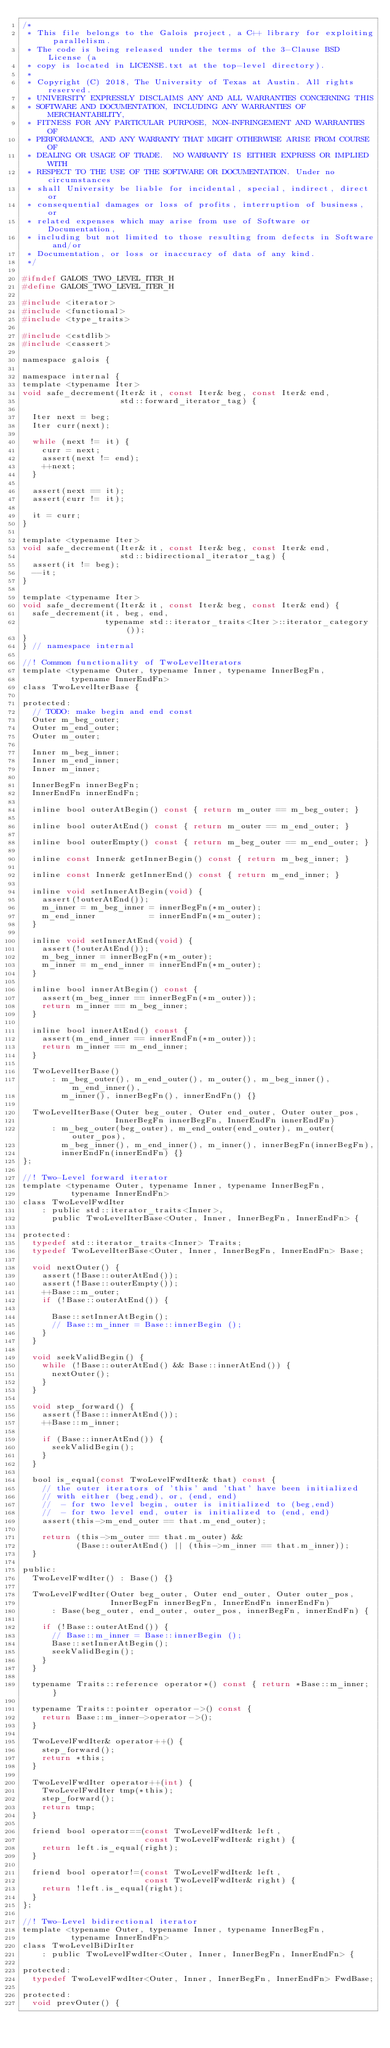<code> <loc_0><loc_0><loc_500><loc_500><_C_>/*
 * This file belongs to the Galois project, a C++ library for exploiting parallelism.
 * The code is being released under the terms of the 3-Clause BSD License (a
 * copy is located in LICENSE.txt at the top-level directory).
 *
 * Copyright (C) 2018, The University of Texas at Austin. All rights reserved.
 * UNIVERSITY EXPRESSLY DISCLAIMS ANY AND ALL WARRANTIES CONCERNING THIS
 * SOFTWARE AND DOCUMENTATION, INCLUDING ANY WARRANTIES OF MERCHANTABILITY,
 * FITNESS FOR ANY PARTICULAR PURPOSE, NON-INFRINGEMENT AND WARRANTIES OF
 * PERFORMANCE, AND ANY WARRANTY THAT MIGHT OTHERWISE ARISE FROM COURSE OF
 * DEALING OR USAGE OF TRADE.  NO WARRANTY IS EITHER EXPRESS OR IMPLIED WITH
 * RESPECT TO THE USE OF THE SOFTWARE OR DOCUMENTATION. Under no circumstances
 * shall University be liable for incidental, special, indirect, direct or
 * consequential damages or loss of profits, interruption of business, or
 * related expenses which may arise from use of Software or Documentation,
 * including but not limited to those resulting from defects in Software and/or
 * Documentation, or loss or inaccuracy of data of any kind.
 */

#ifndef GALOIS_TWO_LEVEL_ITER_H
#define GALOIS_TWO_LEVEL_ITER_H

#include <iterator>
#include <functional>
#include <type_traits>

#include <cstdlib>
#include <cassert>

namespace galois {

namespace internal {
template <typename Iter>
void safe_decrement(Iter& it, const Iter& beg, const Iter& end,
                    std::forward_iterator_tag) {

  Iter next = beg;
  Iter curr(next);

  while (next != it) {
    curr = next;
    assert(next != end);
    ++next;
  }

  assert(next == it);
  assert(curr != it);

  it = curr;
}

template <typename Iter>
void safe_decrement(Iter& it, const Iter& beg, const Iter& end,
                    std::bidirectional_iterator_tag) {
  assert(it != beg);
  --it;
}

template <typename Iter>
void safe_decrement(Iter& it, const Iter& beg, const Iter& end) {
  safe_decrement(it, beg, end,
                 typename std::iterator_traits<Iter>::iterator_category());
}
} // namespace internal

//! Common functionality of TwoLevelIterators
template <typename Outer, typename Inner, typename InnerBegFn,
          typename InnerEndFn>
class TwoLevelIterBase {

protected:
  // TODO: make begin and end const
  Outer m_beg_outer;
  Outer m_end_outer;
  Outer m_outer;

  Inner m_beg_inner;
  Inner m_end_inner;
  Inner m_inner;

  InnerBegFn innerBegFn;
  InnerEndFn innerEndFn;

  inline bool outerAtBegin() const { return m_outer == m_beg_outer; }

  inline bool outerAtEnd() const { return m_outer == m_end_outer; }

  inline bool outerEmpty() const { return m_beg_outer == m_end_outer; }

  inline const Inner& getInnerBegin() const { return m_beg_inner; }

  inline const Inner& getInnerEnd() const { return m_end_inner; }

  inline void setInnerAtBegin(void) {
    assert(!outerAtEnd());
    m_inner = m_beg_inner = innerBegFn(*m_outer);
    m_end_inner           = innerEndFn(*m_outer);
  }

  inline void setInnerAtEnd(void) {
    assert(!outerAtEnd());
    m_beg_inner = innerBegFn(*m_outer);
    m_inner = m_end_inner = innerEndFn(*m_outer);
  }

  inline bool innerAtBegin() const {
    assert(m_beg_inner == innerBegFn(*m_outer));
    return m_inner == m_beg_inner;
  }

  inline bool innerAtEnd() const {
    assert(m_end_inner == innerEndFn(*m_outer));
    return m_inner == m_end_inner;
  }

  TwoLevelIterBase()
      : m_beg_outer(), m_end_outer(), m_outer(), m_beg_inner(), m_end_inner(),
        m_inner(), innerBegFn(), innerEndFn() {}

  TwoLevelIterBase(Outer beg_outer, Outer end_outer, Outer outer_pos,
                   InnerBegFn innerBegFn, InnerEndFn innerEndFn)
      : m_beg_outer(beg_outer), m_end_outer(end_outer), m_outer(outer_pos),
        m_beg_inner(), m_end_inner(), m_inner(), innerBegFn(innerBegFn),
        innerEndFn(innerEndFn) {}
};

//! Two-Level forward iterator
template <typename Outer, typename Inner, typename InnerBegFn,
          typename InnerEndFn>
class TwoLevelFwdIter
    : public std::iterator_traits<Inner>,
      public TwoLevelIterBase<Outer, Inner, InnerBegFn, InnerEndFn> {

protected:
  typedef std::iterator_traits<Inner> Traits;
  typedef TwoLevelIterBase<Outer, Inner, InnerBegFn, InnerEndFn> Base;

  void nextOuter() {
    assert(!Base::outerAtEnd());
    assert(!Base::outerEmpty());
    ++Base::m_outer;
    if (!Base::outerAtEnd()) {

      Base::setInnerAtBegin();
      // Base::m_inner = Base::innerBegin ();
    }
  }

  void seekValidBegin() {
    while (!Base::outerAtEnd() && Base::innerAtEnd()) {
      nextOuter();
    }
  }

  void step_forward() {
    assert(!Base::innerAtEnd());
    ++Base::m_inner;

    if (Base::innerAtEnd()) {
      seekValidBegin();
    }
  }

  bool is_equal(const TwoLevelFwdIter& that) const {
    // the outer iterators of 'this' and 'that' have been initialized
    // with either (beg,end), or, (end, end)
    //  - for two level begin, outer is initialized to (beg,end)
    //  - for two level end, outer is initialized to (end, end)
    assert(this->m_end_outer == that.m_end_outer);

    return (this->m_outer == that.m_outer) &&
           (Base::outerAtEnd() || (this->m_inner == that.m_inner));
  }

public:
  TwoLevelFwdIter() : Base() {}

  TwoLevelFwdIter(Outer beg_outer, Outer end_outer, Outer outer_pos,
                  InnerBegFn innerBegFn, InnerEndFn innerEndFn)
      : Base(beg_outer, end_outer, outer_pos, innerBegFn, innerEndFn) {

    if (!Base::outerAtEnd()) {
      // Base::m_inner = Base::innerBegin ();
      Base::setInnerAtBegin();
      seekValidBegin();
    }
  }

  typename Traits::reference operator*() const { return *Base::m_inner; }

  typename Traits::pointer operator->() const {
    return Base::m_inner->operator->();
  }

  TwoLevelFwdIter& operator++() {
    step_forward();
    return *this;
  }

  TwoLevelFwdIter operator++(int) {
    TwoLevelFwdIter tmp(*this);
    step_forward();
    return tmp;
  }

  friend bool operator==(const TwoLevelFwdIter& left,
                         const TwoLevelFwdIter& right) {
    return left.is_equal(right);
  }

  friend bool operator!=(const TwoLevelFwdIter& left,
                         const TwoLevelFwdIter& right) {
    return !left.is_equal(right);
  }
};

//! Two-Level bidirectional iterator
template <typename Outer, typename Inner, typename InnerBegFn,
          typename InnerEndFn>
class TwoLevelBiDirIter
    : public TwoLevelFwdIter<Outer, Inner, InnerBegFn, InnerEndFn> {

protected:
  typedef TwoLevelFwdIter<Outer, Inner, InnerBegFn, InnerEndFn> FwdBase;

protected:
  void prevOuter() {</code> 